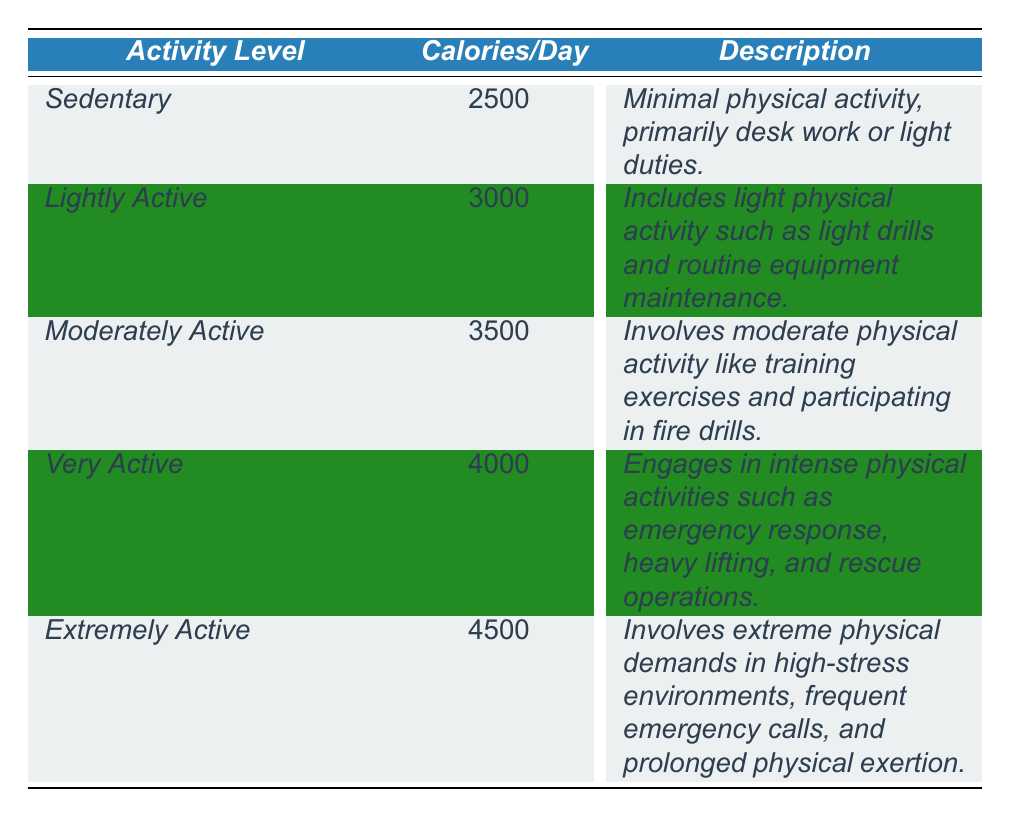What is the caloric intake for a "Very Active" firefighter? The table lists the caloric intake for "Very Active" firefighters as 4000 calories per day.
Answer: 4000 calories What activity level requires the highest caloric intake? The "Extremely Active" category, which requires 4500 calories per day, is the highest in caloric intake.
Answer: Extremely Active How many calories does a "Moderately Active" firefighter require compared to a "Lightly Active" firefighter? A "Moderately Active" firefighter requires 3500 calories, while a "Lightly Active" firefighter requires 3000 calories. The difference is 3500 - 3000 = 500 calories.
Answer: 500 calories Is the caloric intake for "Sedentary" firefighters more than 2400 calories? The caloric intake for "Sedentary" firefighters is 2500 calories, which is indeed more than 2400 calories.
Answer: Yes What is the average caloric intake across all activity levels listed? To find the average, add all the calories: 2500 + 3000 + 3500 + 4000 + 4500 = 22500; then divide by 5 (the number of activity levels): 22500 / 5 = 4500 calories.
Answer: 4500 calories Which activity level has a daily caloric intake closest to 3500 calories? The "Moderately Active" level has a caloric intake of exactly 3500 calories, which is the target value.
Answer: Moderately Active If a firefighter works at the "Sedentary" level for a week, how many total calories would they require? For "Sedentary" firefighters, the daily requirement is 2500 calories. Over a week (7 days), the total is 2500 * 7 = 17500 calories.
Answer: 17500 calories Is the daily caloric requirement for "Lightly Active" firefighters greater than that for "Sedentary" firefighters? "Lightly Active" firefighters require 3000 calories, which is greater than the 2500 calories needed by "Sedentary" firefighters.
Answer: Yes 